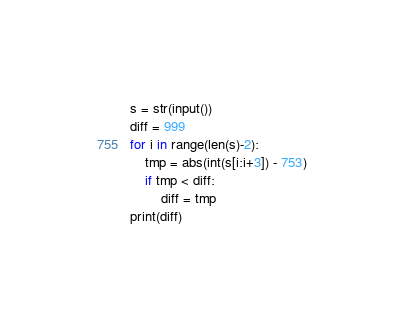Convert code to text. <code><loc_0><loc_0><loc_500><loc_500><_Python_>s = str(input())
diff = 999
for i in range(len(s)-2):
    tmp = abs(int(s[i:i+3]) - 753)
    if tmp < diff:
        diff = tmp
print(diff)</code> 